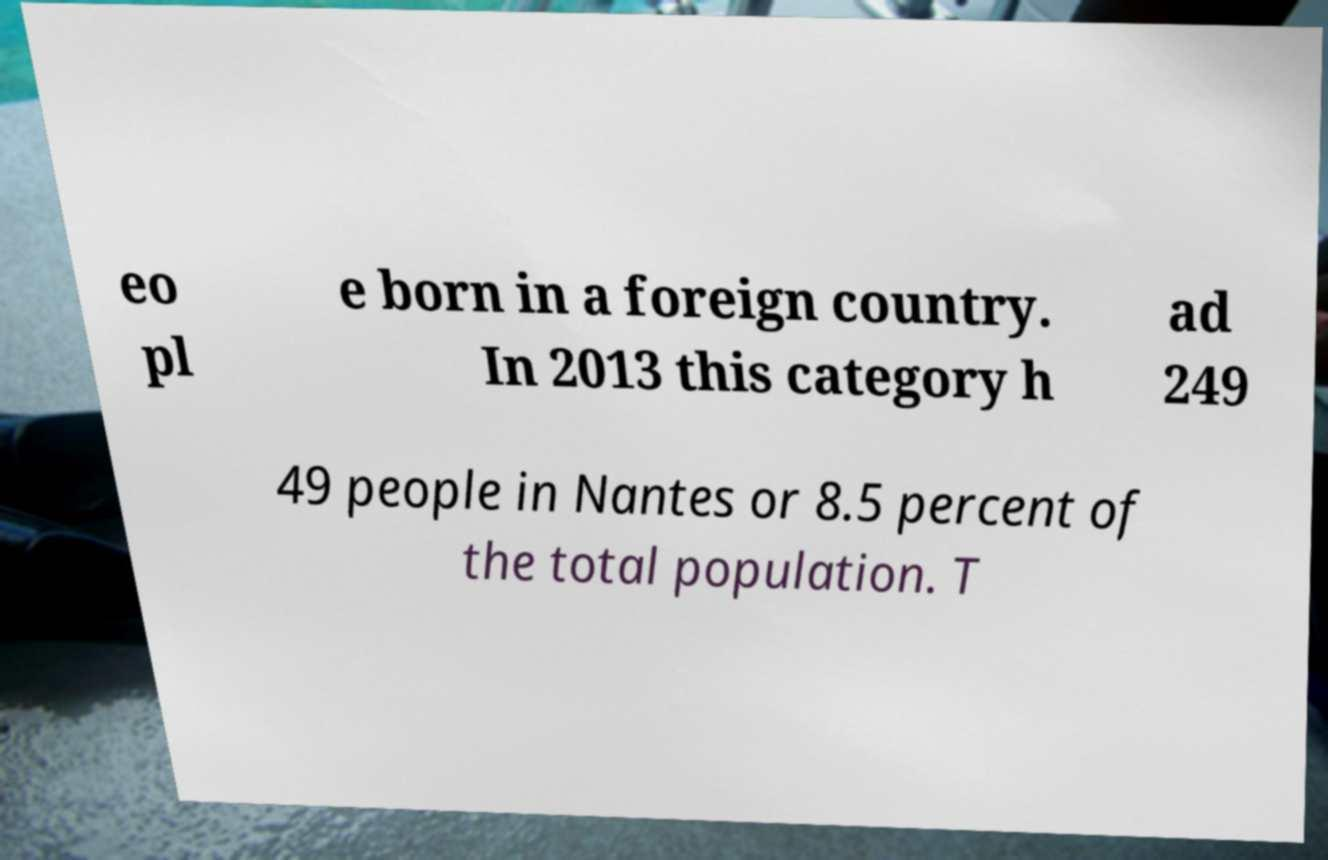What messages or text are displayed in this image? I need them in a readable, typed format. eo pl e born in a foreign country. In 2013 this category h ad 249 49 people in Nantes or 8.5 percent of the total population. T 